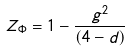<formula> <loc_0><loc_0><loc_500><loc_500>Z _ { \Phi } = 1 - \frac { g ^ { 2 } } { ( 4 - d ) }</formula> 